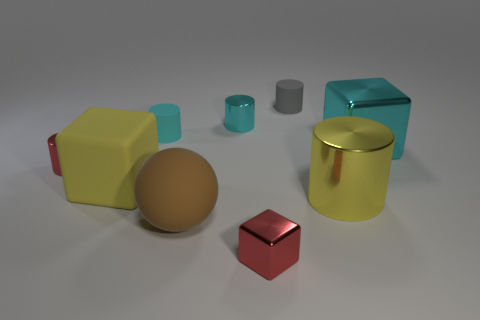Subtract all red cylinders. How many cylinders are left? 4 Subtract all yellow cylinders. How many cylinders are left? 4 Subtract all purple cylinders. Subtract all red balls. How many cylinders are left? 5 Subtract all balls. How many objects are left? 8 Add 6 spheres. How many spheres are left? 7 Add 4 red cubes. How many red cubes exist? 5 Subtract 0 green cylinders. How many objects are left? 9 Subtract all yellow metal cylinders. Subtract all yellow metal things. How many objects are left? 7 